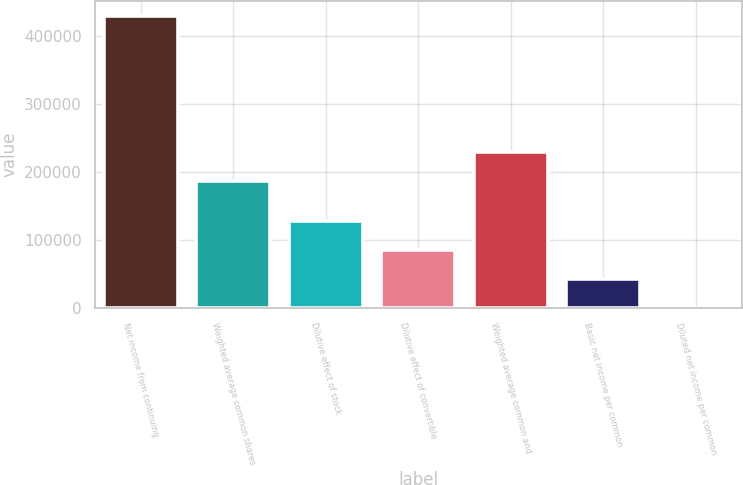Convert chart to OTSL. <chart><loc_0><loc_0><loc_500><loc_500><bar_chart><fcel>Net income from continuing<fcel>Weighted average common shares<fcel>Dilutive effect of stock<fcel>Dilutive effect of convertible<fcel>Weighted average common and<fcel>Basic net income per common<fcel>Diluted net income per common<nl><fcel>429167<fcel>187066<fcel>128752<fcel>85835.2<fcel>229982<fcel>42918.7<fcel>2.2<nl></chart> 